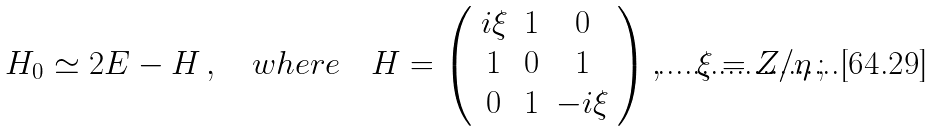Convert formula to latex. <formula><loc_0><loc_0><loc_500><loc_500>H _ { 0 } \simeq 2 E - H \, , \quad w h e r e \quad H = \left ( \begin{array} { c c c } i \xi & 1 & 0 \\ 1 & 0 & 1 \\ 0 & 1 & - i \xi \end{array} \right ) , \quad \xi = Z / \eta \, ;</formula> 